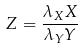<formula> <loc_0><loc_0><loc_500><loc_500>Z = \frac { \lambda _ { X } X } { \lambda _ { Y } Y }</formula> 